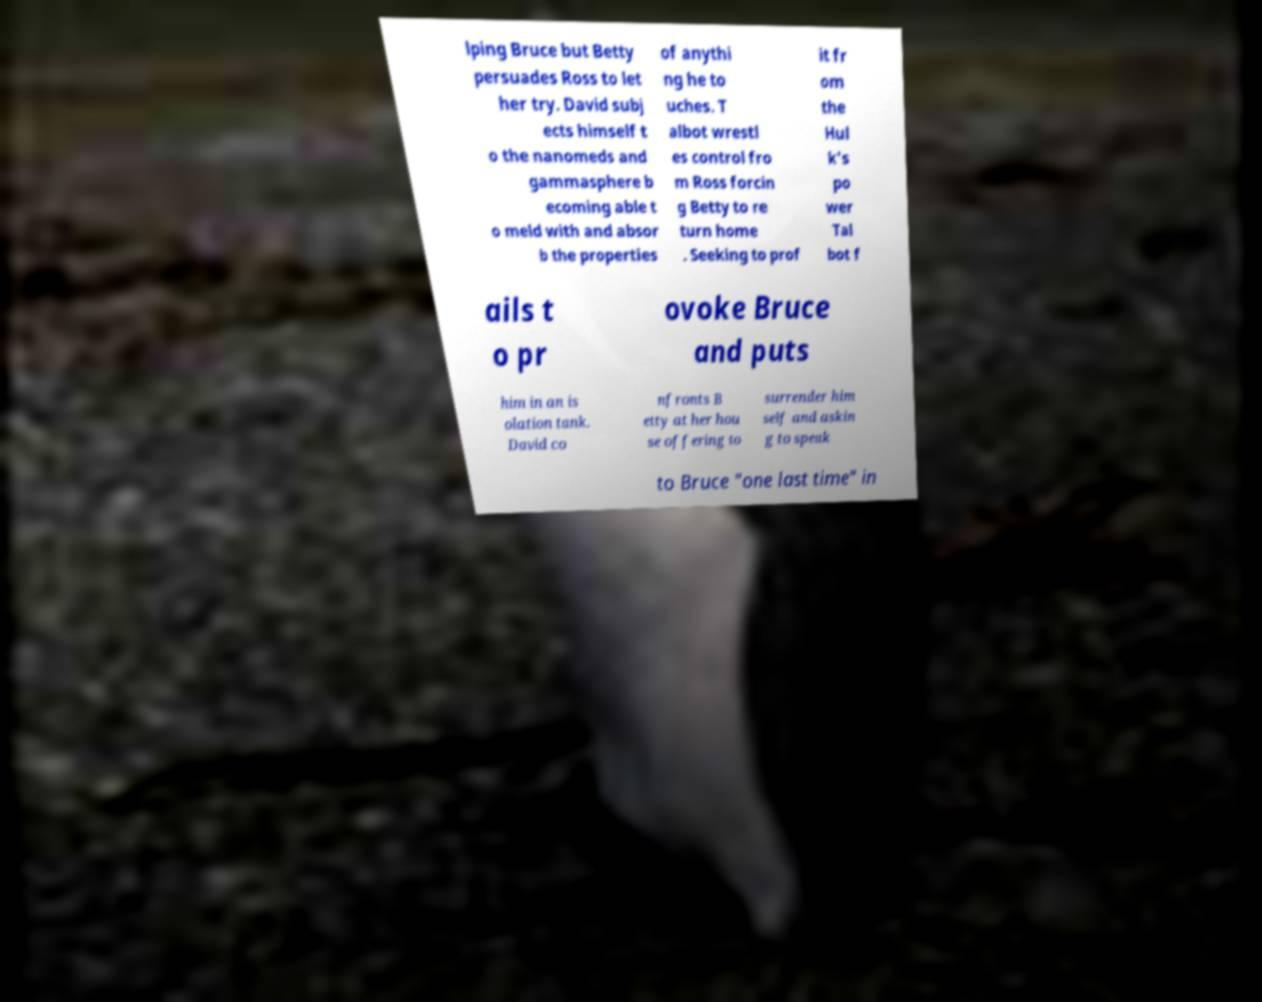There's text embedded in this image that I need extracted. Can you transcribe it verbatim? lping Bruce but Betty persuades Ross to let her try. David subj ects himself t o the nanomeds and gammasphere b ecoming able t o meld with and absor b the properties of anythi ng he to uches. T albot wrestl es control fro m Ross forcin g Betty to re turn home . Seeking to prof it fr om the Hul k's po wer Tal bot f ails t o pr ovoke Bruce and puts him in an is olation tank. David co nfronts B etty at her hou se offering to surrender him self and askin g to speak to Bruce "one last time" in 